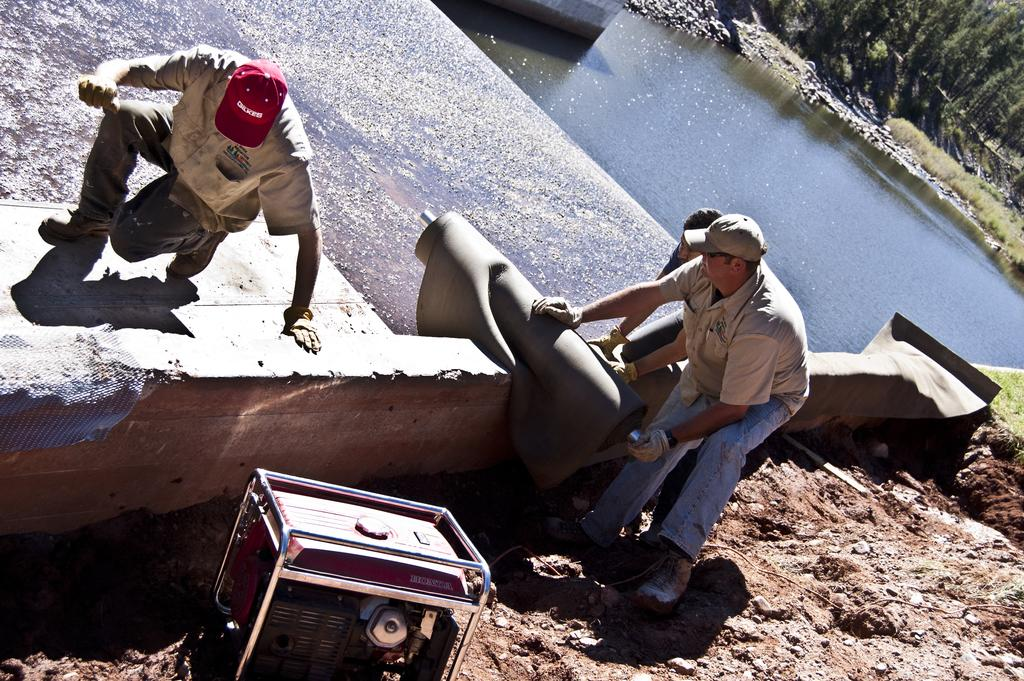What is located at the bottom of the image? There is an inverter at the bottom of the image. What type of natural elements can be seen in the image? There are stones in the image. Who or what is in the foreground of the image? There are people in the foreground of the image. What can be seen in the background of the image? There is water and trees visible in the background of the image. Can you hear the people laughing in the image? There is no sound present in the image, so it is not possible to hear any laughter. 